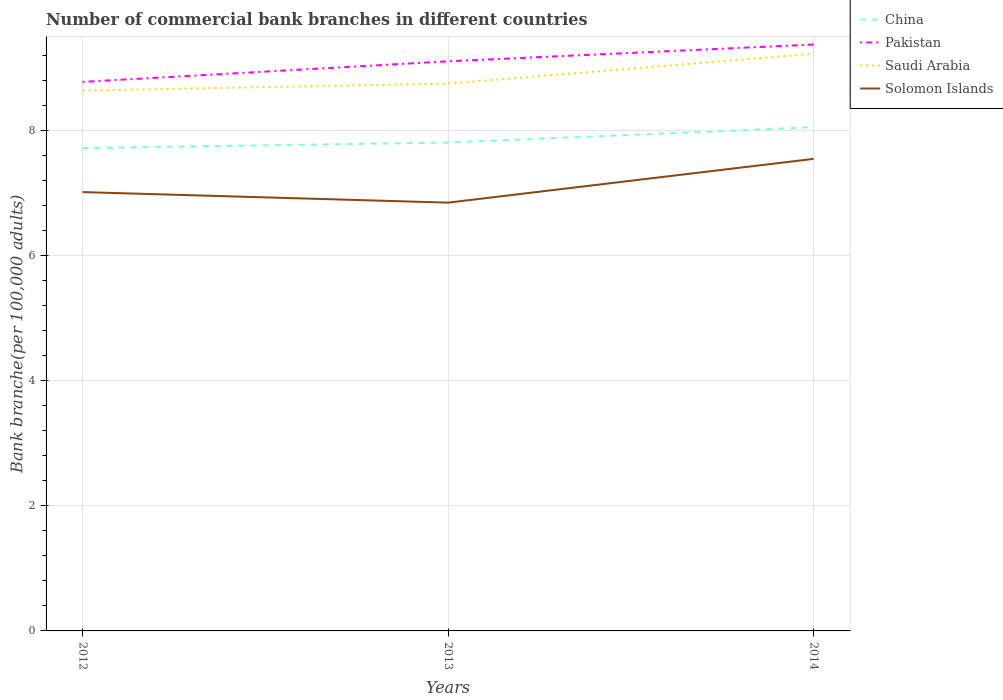How many different coloured lines are there?
Ensure brevity in your answer.  4. Is the number of lines equal to the number of legend labels?
Give a very brief answer. Yes. Across all years, what is the maximum number of commercial bank branches in China?
Make the answer very short. 7.72. What is the total number of commercial bank branches in Solomon Islands in the graph?
Your answer should be compact. -0.53. What is the difference between the highest and the second highest number of commercial bank branches in China?
Your response must be concise. 0.33. How many years are there in the graph?
Your answer should be compact. 3. What is the difference between two consecutive major ticks on the Y-axis?
Your answer should be very brief. 2. Are the values on the major ticks of Y-axis written in scientific E-notation?
Provide a succinct answer. No. Does the graph contain grids?
Your answer should be compact. Yes. Where does the legend appear in the graph?
Provide a short and direct response. Top right. How many legend labels are there?
Give a very brief answer. 4. How are the legend labels stacked?
Give a very brief answer. Vertical. What is the title of the graph?
Give a very brief answer. Number of commercial bank branches in different countries. What is the label or title of the Y-axis?
Offer a terse response. Bank branche(per 100,0 adults). What is the Bank branche(per 100,000 adults) in China in 2012?
Offer a very short reply. 7.72. What is the Bank branche(per 100,000 adults) of Pakistan in 2012?
Your answer should be very brief. 8.78. What is the Bank branche(per 100,000 adults) in Saudi Arabia in 2012?
Give a very brief answer. 8.64. What is the Bank branche(per 100,000 adults) in Solomon Islands in 2012?
Make the answer very short. 7.02. What is the Bank branche(per 100,000 adults) in China in 2013?
Your answer should be compact. 7.81. What is the Bank branche(per 100,000 adults) in Pakistan in 2013?
Offer a terse response. 9.11. What is the Bank branche(per 100,000 adults) of Saudi Arabia in 2013?
Your answer should be compact. 8.75. What is the Bank branche(per 100,000 adults) in Solomon Islands in 2013?
Offer a terse response. 6.85. What is the Bank branche(per 100,000 adults) in China in 2014?
Make the answer very short. 8.06. What is the Bank branche(per 100,000 adults) in Pakistan in 2014?
Your answer should be compact. 9.38. What is the Bank branche(per 100,000 adults) in Saudi Arabia in 2014?
Make the answer very short. 9.23. What is the Bank branche(per 100,000 adults) in Solomon Islands in 2014?
Provide a short and direct response. 7.55. Across all years, what is the maximum Bank branche(per 100,000 adults) in China?
Offer a terse response. 8.06. Across all years, what is the maximum Bank branche(per 100,000 adults) in Pakistan?
Offer a very short reply. 9.38. Across all years, what is the maximum Bank branche(per 100,000 adults) of Saudi Arabia?
Ensure brevity in your answer.  9.23. Across all years, what is the maximum Bank branche(per 100,000 adults) in Solomon Islands?
Your answer should be very brief. 7.55. Across all years, what is the minimum Bank branche(per 100,000 adults) of China?
Your answer should be compact. 7.72. Across all years, what is the minimum Bank branche(per 100,000 adults) in Pakistan?
Your response must be concise. 8.78. Across all years, what is the minimum Bank branche(per 100,000 adults) of Saudi Arabia?
Ensure brevity in your answer.  8.64. Across all years, what is the minimum Bank branche(per 100,000 adults) of Solomon Islands?
Make the answer very short. 6.85. What is the total Bank branche(per 100,000 adults) of China in the graph?
Ensure brevity in your answer.  23.59. What is the total Bank branche(per 100,000 adults) in Pakistan in the graph?
Provide a succinct answer. 27.27. What is the total Bank branche(per 100,000 adults) in Saudi Arabia in the graph?
Your answer should be compact. 26.63. What is the total Bank branche(per 100,000 adults) of Solomon Islands in the graph?
Offer a very short reply. 21.42. What is the difference between the Bank branche(per 100,000 adults) of China in 2012 and that in 2013?
Make the answer very short. -0.09. What is the difference between the Bank branche(per 100,000 adults) of Pakistan in 2012 and that in 2013?
Keep it short and to the point. -0.33. What is the difference between the Bank branche(per 100,000 adults) in Saudi Arabia in 2012 and that in 2013?
Your answer should be compact. -0.11. What is the difference between the Bank branche(per 100,000 adults) of Solomon Islands in 2012 and that in 2013?
Your answer should be very brief. 0.17. What is the difference between the Bank branche(per 100,000 adults) of China in 2012 and that in 2014?
Ensure brevity in your answer.  -0.33. What is the difference between the Bank branche(per 100,000 adults) in Pakistan in 2012 and that in 2014?
Offer a terse response. -0.6. What is the difference between the Bank branche(per 100,000 adults) of Saudi Arabia in 2012 and that in 2014?
Offer a terse response. -0.59. What is the difference between the Bank branche(per 100,000 adults) in Solomon Islands in 2012 and that in 2014?
Ensure brevity in your answer.  -0.53. What is the difference between the Bank branche(per 100,000 adults) of China in 2013 and that in 2014?
Give a very brief answer. -0.24. What is the difference between the Bank branche(per 100,000 adults) in Pakistan in 2013 and that in 2014?
Ensure brevity in your answer.  -0.27. What is the difference between the Bank branche(per 100,000 adults) of Saudi Arabia in 2013 and that in 2014?
Offer a very short reply. -0.48. What is the difference between the Bank branche(per 100,000 adults) of China in 2012 and the Bank branche(per 100,000 adults) of Pakistan in 2013?
Provide a succinct answer. -1.39. What is the difference between the Bank branche(per 100,000 adults) of China in 2012 and the Bank branche(per 100,000 adults) of Saudi Arabia in 2013?
Your response must be concise. -1.03. What is the difference between the Bank branche(per 100,000 adults) in China in 2012 and the Bank branche(per 100,000 adults) in Solomon Islands in 2013?
Your response must be concise. 0.87. What is the difference between the Bank branche(per 100,000 adults) of Pakistan in 2012 and the Bank branche(per 100,000 adults) of Saudi Arabia in 2013?
Give a very brief answer. 0.03. What is the difference between the Bank branche(per 100,000 adults) of Pakistan in 2012 and the Bank branche(per 100,000 adults) of Solomon Islands in 2013?
Your answer should be compact. 1.93. What is the difference between the Bank branche(per 100,000 adults) in Saudi Arabia in 2012 and the Bank branche(per 100,000 adults) in Solomon Islands in 2013?
Make the answer very short. 1.79. What is the difference between the Bank branche(per 100,000 adults) of China in 2012 and the Bank branche(per 100,000 adults) of Pakistan in 2014?
Keep it short and to the point. -1.66. What is the difference between the Bank branche(per 100,000 adults) in China in 2012 and the Bank branche(per 100,000 adults) in Saudi Arabia in 2014?
Provide a short and direct response. -1.51. What is the difference between the Bank branche(per 100,000 adults) of China in 2012 and the Bank branche(per 100,000 adults) of Solomon Islands in 2014?
Offer a very short reply. 0.17. What is the difference between the Bank branche(per 100,000 adults) of Pakistan in 2012 and the Bank branche(per 100,000 adults) of Saudi Arabia in 2014?
Provide a succinct answer. -0.45. What is the difference between the Bank branche(per 100,000 adults) in Pakistan in 2012 and the Bank branche(per 100,000 adults) in Solomon Islands in 2014?
Provide a short and direct response. 1.23. What is the difference between the Bank branche(per 100,000 adults) in Saudi Arabia in 2012 and the Bank branche(per 100,000 adults) in Solomon Islands in 2014?
Your response must be concise. 1.09. What is the difference between the Bank branche(per 100,000 adults) in China in 2013 and the Bank branche(per 100,000 adults) in Pakistan in 2014?
Your answer should be very brief. -1.57. What is the difference between the Bank branche(per 100,000 adults) in China in 2013 and the Bank branche(per 100,000 adults) in Saudi Arabia in 2014?
Offer a terse response. -1.42. What is the difference between the Bank branche(per 100,000 adults) in China in 2013 and the Bank branche(per 100,000 adults) in Solomon Islands in 2014?
Provide a succinct answer. 0.26. What is the difference between the Bank branche(per 100,000 adults) in Pakistan in 2013 and the Bank branche(per 100,000 adults) in Saudi Arabia in 2014?
Keep it short and to the point. -0.12. What is the difference between the Bank branche(per 100,000 adults) of Pakistan in 2013 and the Bank branche(per 100,000 adults) of Solomon Islands in 2014?
Your answer should be very brief. 1.56. What is the difference between the Bank branche(per 100,000 adults) in Saudi Arabia in 2013 and the Bank branche(per 100,000 adults) in Solomon Islands in 2014?
Give a very brief answer. 1.2. What is the average Bank branche(per 100,000 adults) of China per year?
Make the answer very short. 7.86. What is the average Bank branche(per 100,000 adults) of Pakistan per year?
Offer a terse response. 9.09. What is the average Bank branche(per 100,000 adults) in Saudi Arabia per year?
Provide a short and direct response. 8.88. What is the average Bank branche(per 100,000 adults) in Solomon Islands per year?
Make the answer very short. 7.14. In the year 2012, what is the difference between the Bank branche(per 100,000 adults) in China and Bank branche(per 100,000 adults) in Pakistan?
Keep it short and to the point. -1.06. In the year 2012, what is the difference between the Bank branche(per 100,000 adults) of China and Bank branche(per 100,000 adults) of Saudi Arabia?
Keep it short and to the point. -0.92. In the year 2012, what is the difference between the Bank branche(per 100,000 adults) in China and Bank branche(per 100,000 adults) in Solomon Islands?
Provide a succinct answer. 0.71. In the year 2012, what is the difference between the Bank branche(per 100,000 adults) in Pakistan and Bank branche(per 100,000 adults) in Saudi Arabia?
Offer a very short reply. 0.14. In the year 2012, what is the difference between the Bank branche(per 100,000 adults) in Pakistan and Bank branche(per 100,000 adults) in Solomon Islands?
Your answer should be very brief. 1.76. In the year 2012, what is the difference between the Bank branche(per 100,000 adults) in Saudi Arabia and Bank branche(per 100,000 adults) in Solomon Islands?
Make the answer very short. 1.62. In the year 2013, what is the difference between the Bank branche(per 100,000 adults) of China and Bank branche(per 100,000 adults) of Pakistan?
Your answer should be very brief. -1.3. In the year 2013, what is the difference between the Bank branche(per 100,000 adults) in China and Bank branche(per 100,000 adults) in Saudi Arabia?
Offer a terse response. -0.94. In the year 2013, what is the difference between the Bank branche(per 100,000 adults) of China and Bank branche(per 100,000 adults) of Solomon Islands?
Your answer should be very brief. 0.96. In the year 2013, what is the difference between the Bank branche(per 100,000 adults) in Pakistan and Bank branche(per 100,000 adults) in Saudi Arabia?
Provide a succinct answer. 0.36. In the year 2013, what is the difference between the Bank branche(per 100,000 adults) of Pakistan and Bank branche(per 100,000 adults) of Solomon Islands?
Your answer should be compact. 2.26. In the year 2013, what is the difference between the Bank branche(per 100,000 adults) of Saudi Arabia and Bank branche(per 100,000 adults) of Solomon Islands?
Make the answer very short. 1.9. In the year 2014, what is the difference between the Bank branche(per 100,000 adults) of China and Bank branche(per 100,000 adults) of Pakistan?
Provide a short and direct response. -1.32. In the year 2014, what is the difference between the Bank branche(per 100,000 adults) in China and Bank branche(per 100,000 adults) in Saudi Arabia?
Give a very brief answer. -1.18. In the year 2014, what is the difference between the Bank branche(per 100,000 adults) in China and Bank branche(per 100,000 adults) in Solomon Islands?
Keep it short and to the point. 0.51. In the year 2014, what is the difference between the Bank branche(per 100,000 adults) of Pakistan and Bank branche(per 100,000 adults) of Saudi Arabia?
Offer a terse response. 0.15. In the year 2014, what is the difference between the Bank branche(per 100,000 adults) of Pakistan and Bank branche(per 100,000 adults) of Solomon Islands?
Make the answer very short. 1.83. In the year 2014, what is the difference between the Bank branche(per 100,000 adults) of Saudi Arabia and Bank branche(per 100,000 adults) of Solomon Islands?
Your answer should be compact. 1.68. What is the ratio of the Bank branche(per 100,000 adults) in Pakistan in 2012 to that in 2013?
Give a very brief answer. 0.96. What is the ratio of the Bank branche(per 100,000 adults) in Saudi Arabia in 2012 to that in 2013?
Your response must be concise. 0.99. What is the ratio of the Bank branche(per 100,000 adults) in Solomon Islands in 2012 to that in 2013?
Make the answer very short. 1.02. What is the ratio of the Bank branche(per 100,000 adults) in China in 2012 to that in 2014?
Your answer should be very brief. 0.96. What is the ratio of the Bank branche(per 100,000 adults) in Pakistan in 2012 to that in 2014?
Your response must be concise. 0.94. What is the ratio of the Bank branche(per 100,000 adults) in Saudi Arabia in 2012 to that in 2014?
Your answer should be very brief. 0.94. What is the ratio of the Bank branche(per 100,000 adults) in Solomon Islands in 2012 to that in 2014?
Give a very brief answer. 0.93. What is the ratio of the Bank branche(per 100,000 adults) in China in 2013 to that in 2014?
Your response must be concise. 0.97. What is the ratio of the Bank branche(per 100,000 adults) in Pakistan in 2013 to that in 2014?
Offer a very short reply. 0.97. What is the ratio of the Bank branche(per 100,000 adults) in Saudi Arabia in 2013 to that in 2014?
Your answer should be compact. 0.95. What is the ratio of the Bank branche(per 100,000 adults) in Solomon Islands in 2013 to that in 2014?
Your response must be concise. 0.91. What is the difference between the highest and the second highest Bank branche(per 100,000 adults) of China?
Give a very brief answer. 0.24. What is the difference between the highest and the second highest Bank branche(per 100,000 adults) of Pakistan?
Your response must be concise. 0.27. What is the difference between the highest and the second highest Bank branche(per 100,000 adults) in Saudi Arabia?
Your response must be concise. 0.48. What is the difference between the highest and the second highest Bank branche(per 100,000 adults) of Solomon Islands?
Provide a succinct answer. 0.53. What is the difference between the highest and the lowest Bank branche(per 100,000 adults) in China?
Your response must be concise. 0.33. What is the difference between the highest and the lowest Bank branche(per 100,000 adults) of Pakistan?
Ensure brevity in your answer.  0.6. What is the difference between the highest and the lowest Bank branche(per 100,000 adults) in Saudi Arabia?
Your response must be concise. 0.59. What is the difference between the highest and the lowest Bank branche(per 100,000 adults) in Solomon Islands?
Your response must be concise. 0.7. 